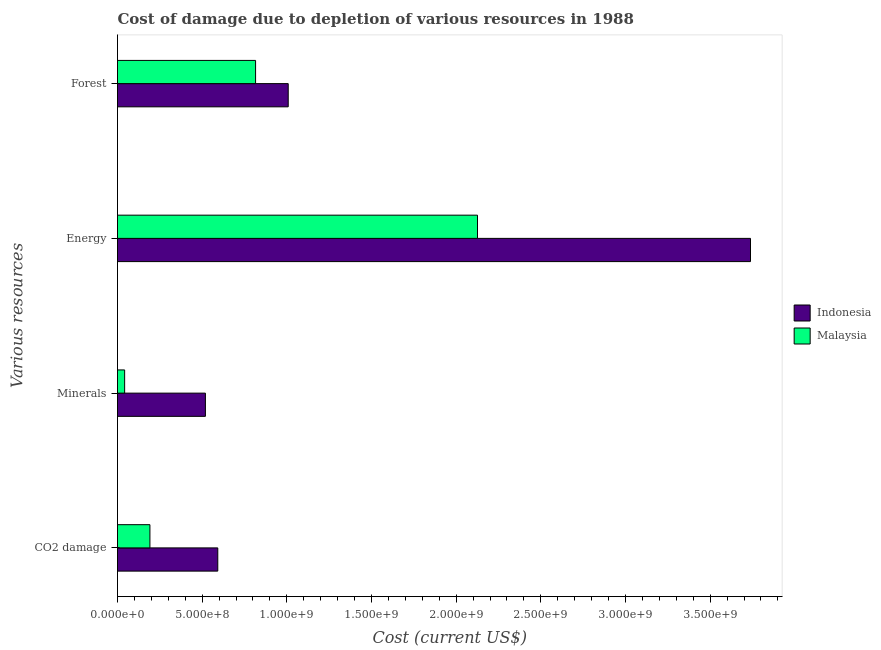How many groups of bars are there?
Ensure brevity in your answer.  4. Are the number of bars per tick equal to the number of legend labels?
Your answer should be very brief. Yes. How many bars are there on the 3rd tick from the bottom?
Make the answer very short. 2. What is the label of the 4th group of bars from the top?
Your answer should be very brief. CO2 damage. What is the cost of damage due to depletion of energy in Indonesia?
Give a very brief answer. 3.74e+09. Across all countries, what is the maximum cost of damage due to depletion of minerals?
Your answer should be very brief. 5.19e+08. Across all countries, what is the minimum cost of damage due to depletion of coal?
Provide a succinct answer. 1.91e+08. In which country was the cost of damage due to depletion of forests minimum?
Offer a terse response. Malaysia. What is the total cost of damage due to depletion of forests in the graph?
Offer a terse response. 1.82e+09. What is the difference between the cost of damage due to depletion of coal in Indonesia and that in Malaysia?
Your answer should be compact. 4.01e+08. What is the difference between the cost of damage due to depletion of forests in Indonesia and the cost of damage due to depletion of minerals in Malaysia?
Offer a very short reply. 9.66e+08. What is the average cost of damage due to depletion of coal per country?
Offer a terse response. 3.92e+08. What is the difference between the cost of damage due to depletion of coal and cost of damage due to depletion of minerals in Malaysia?
Your answer should be compact. 1.49e+08. In how many countries, is the cost of damage due to depletion of energy greater than 3300000000 US$?
Your answer should be very brief. 1. What is the ratio of the cost of damage due to depletion of minerals in Indonesia to that in Malaysia?
Offer a terse response. 12.32. Is the cost of damage due to depletion of coal in Malaysia less than that in Indonesia?
Your answer should be very brief. Yes. Is the difference between the cost of damage due to depletion of forests in Malaysia and Indonesia greater than the difference between the cost of damage due to depletion of coal in Malaysia and Indonesia?
Provide a short and direct response. Yes. What is the difference between the highest and the second highest cost of damage due to depletion of forests?
Offer a very short reply. 1.93e+08. What is the difference between the highest and the lowest cost of damage due to depletion of energy?
Keep it short and to the point. 1.61e+09. Is the sum of the cost of damage due to depletion of energy in Malaysia and Indonesia greater than the maximum cost of damage due to depletion of forests across all countries?
Offer a terse response. Yes. What does the 1st bar from the top in Minerals represents?
Keep it short and to the point. Malaysia. What does the 2nd bar from the bottom in Energy represents?
Keep it short and to the point. Malaysia. Is it the case that in every country, the sum of the cost of damage due to depletion of coal and cost of damage due to depletion of minerals is greater than the cost of damage due to depletion of energy?
Give a very brief answer. No. Are all the bars in the graph horizontal?
Offer a very short reply. Yes. Are the values on the major ticks of X-axis written in scientific E-notation?
Provide a short and direct response. Yes. Does the graph contain any zero values?
Give a very brief answer. No. Does the graph contain grids?
Provide a short and direct response. No. Where does the legend appear in the graph?
Your answer should be compact. Center right. How are the legend labels stacked?
Your response must be concise. Vertical. What is the title of the graph?
Provide a short and direct response. Cost of damage due to depletion of various resources in 1988 . What is the label or title of the X-axis?
Make the answer very short. Cost (current US$). What is the label or title of the Y-axis?
Give a very brief answer. Various resources. What is the Cost (current US$) in Indonesia in CO2 damage?
Keep it short and to the point. 5.92e+08. What is the Cost (current US$) of Malaysia in CO2 damage?
Give a very brief answer. 1.91e+08. What is the Cost (current US$) of Indonesia in Minerals?
Provide a short and direct response. 5.19e+08. What is the Cost (current US$) of Malaysia in Minerals?
Your answer should be very brief. 4.21e+07. What is the Cost (current US$) of Indonesia in Energy?
Make the answer very short. 3.74e+09. What is the Cost (current US$) in Malaysia in Energy?
Give a very brief answer. 2.13e+09. What is the Cost (current US$) of Indonesia in Forest?
Keep it short and to the point. 1.01e+09. What is the Cost (current US$) in Malaysia in Forest?
Ensure brevity in your answer.  8.15e+08. Across all Various resources, what is the maximum Cost (current US$) of Indonesia?
Keep it short and to the point. 3.74e+09. Across all Various resources, what is the maximum Cost (current US$) of Malaysia?
Give a very brief answer. 2.13e+09. Across all Various resources, what is the minimum Cost (current US$) of Indonesia?
Keep it short and to the point. 5.19e+08. Across all Various resources, what is the minimum Cost (current US$) of Malaysia?
Your response must be concise. 4.21e+07. What is the total Cost (current US$) of Indonesia in the graph?
Make the answer very short. 5.86e+09. What is the total Cost (current US$) of Malaysia in the graph?
Keep it short and to the point. 3.17e+09. What is the difference between the Cost (current US$) in Indonesia in CO2 damage and that in Minerals?
Provide a short and direct response. 7.31e+07. What is the difference between the Cost (current US$) in Malaysia in CO2 damage and that in Minerals?
Your answer should be compact. 1.49e+08. What is the difference between the Cost (current US$) in Indonesia in CO2 damage and that in Energy?
Give a very brief answer. -3.15e+09. What is the difference between the Cost (current US$) in Malaysia in CO2 damage and that in Energy?
Make the answer very short. -1.93e+09. What is the difference between the Cost (current US$) in Indonesia in CO2 damage and that in Forest?
Your answer should be very brief. -4.16e+08. What is the difference between the Cost (current US$) of Malaysia in CO2 damage and that in Forest?
Keep it short and to the point. -6.24e+08. What is the difference between the Cost (current US$) in Indonesia in Minerals and that in Energy?
Ensure brevity in your answer.  -3.22e+09. What is the difference between the Cost (current US$) of Malaysia in Minerals and that in Energy?
Provide a short and direct response. -2.08e+09. What is the difference between the Cost (current US$) of Indonesia in Minerals and that in Forest?
Provide a short and direct response. -4.89e+08. What is the difference between the Cost (current US$) in Malaysia in Minerals and that in Forest?
Provide a short and direct response. -7.73e+08. What is the difference between the Cost (current US$) in Indonesia in Energy and that in Forest?
Provide a short and direct response. 2.73e+09. What is the difference between the Cost (current US$) of Malaysia in Energy and that in Forest?
Offer a very short reply. 1.31e+09. What is the difference between the Cost (current US$) in Indonesia in CO2 damage and the Cost (current US$) in Malaysia in Minerals?
Make the answer very short. 5.50e+08. What is the difference between the Cost (current US$) in Indonesia in CO2 damage and the Cost (current US$) in Malaysia in Energy?
Your response must be concise. -1.53e+09. What is the difference between the Cost (current US$) of Indonesia in CO2 damage and the Cost (current US$) of Malaysia in Forest?
Your answer should be very brief. -2.23e+08. What is the difference between the Cost (current US$) of Indonesia in Minerals and the Cost (current US$) of Malaysia in Energy?
Ensure brevity in your answer.  -1.61e+09. What is the difference between the Cost (current US$) of Indonesia in Minerals and the Cost (current US$) of Malaysia in Forest?
Make the answer very short. -2.96e+08. What is the difference between the Cost (current US$) in Indonesia in Energy and the Cost (current US$) in Malaysia in Forest?
Provide a succinct answer. 2.92e+09. What is the average Cost (current US$) of Indonesia per Various resources?
Your answer should be compact. 1.46e+09. What is the average Cost (current US$) in Malaysia per Various resources?
Ensure brevity in your answer.  7.94e+08. What is the difference between the Cost (current US$) in Indonesia and Cost (current US$) in Malaysia in CO2 damage?
Offer a terse response. 4.01e+08. What is the difference between the Cost (current US$) in Indonesia and Cost (current US$) in Malaysia in Minerals?
Provide a short and direct response. 4.77e+08. What is the difference between the Cost (current US$) in Indonesia and Cost (current US$) in Malaysia in Energy?
Your response must be concise. 1.61e+09. What is the difference between the Cost (current US$) in Indonesia and Cost (current US$) in Malaysia in Forest?
Ensure brevity in your answer.  1.93e+08. What is the ratio of the Cost (current US$) in Indonesia in CO2 damage to that in Minerals?
Your answer should be very brief. 1.14. What is the ratio of the Cost (current US$) of Malaysia in CO2 damage to that in Minerals?
Ensure brevity in your answer.  4.54. What is the ratio of the Cost (current US$) of Indonesia in CO2 damage to that in Energy?
Your answer should be compact. 0.16. What is the ratio of the Cost (current US$) of Malaysia in CO2 damage to that in Energy?
Provide a succinct answer. 0.09. What is the ratio of the Cost (current US$) of Indonesia in CO2 damage to that in Forest?
Provide a succinct answer. 0.59. What is the ratio of the Cost (current US$) of Malaysia in CO2 damage to that in Forest?
Ensure brevity in your answer.  0.23. What is the ratio of the Cost (current US$) in Indonesia in Minerals to that in Energy?
Give a very brief answer. 0.14. What is the ratio of the Cost (current US$) of Malaysia in Minerals to that in Energy?
Your answer should be compact. 0.02. What is the ratio of the Cost (current US$) of Indonesia in Minerals to that in Forest?
Make the answer very short. 0.51. What is the ratio of the Cost (current US$) of Malaysia in Minerals to that in Forest?
Your answer should be very brief. 0.05. What is the ratio of the Cost (current US$) in Indonesia in Energy to that in Forest?
Offer a very short reply. 3.71. What is the ratio of the Cost (current US$) of Malaysia in Energy to that in Forest?
Your answer should be very brief. 2.61. What is the difference between the highest and the second highest Cost (current US$) in Indonesia?
Provide a short and direct response. 2.73e+09. What is the difference between the highest and the second highest Cost (current US$) in Malaysia?
Keep it short and to the point. 1.31e+09. What is the difference between the highest and the lowest Cost (current US$) of Indonesia?
Your answer should be compact. 3.22e+09. What is the difference between the highest and the lowest Cost (current US$) of Malaysia?
Ensure brevity in your answer.  2.08e+09. 